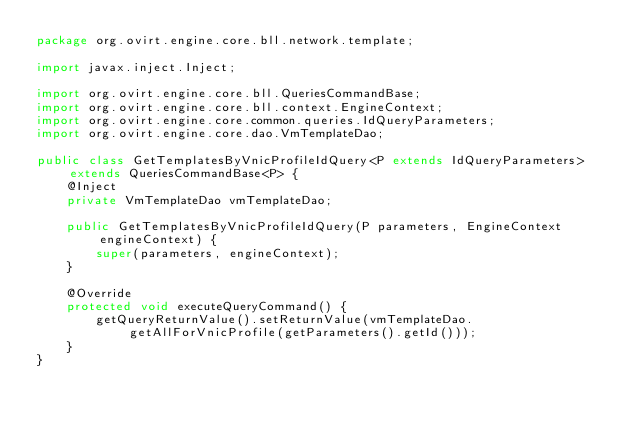<code> <loc_0><loc_0><loc_500><loc_500><_Java_>package org.ovirt.engine.core.bll.network.template;

import javax.inject.Inject;

import org.ovirt.engine.core.bll.QueriesCommandBase;
import org.ovirt.engine.core.bll.context.EngineContext;
import org.ovirt.engine.core.common.queries.IdQueryParameters;
import org.ovirt.engine.core.dao.VmTemplateDao;

public class GetTemplatesByVnicProfileIdQuery<P extends IdQueryParameters> extends QueriesCommandBase<P> {
    @Inject
    private VmTemplateDao vmTemplateDao;

    public GetTemplatesByVnicProfileIdQuery(P parameters, EngineContext engineContext) {
        super(parameters, engineContext);
    }

    @Override
    protected void executeQueryCommand() {
        getQueryReturnValue().setReturnValue(vmTemplateDao.getAllForVnicProfile(getParameters().getId()));
    }
}
</code> 